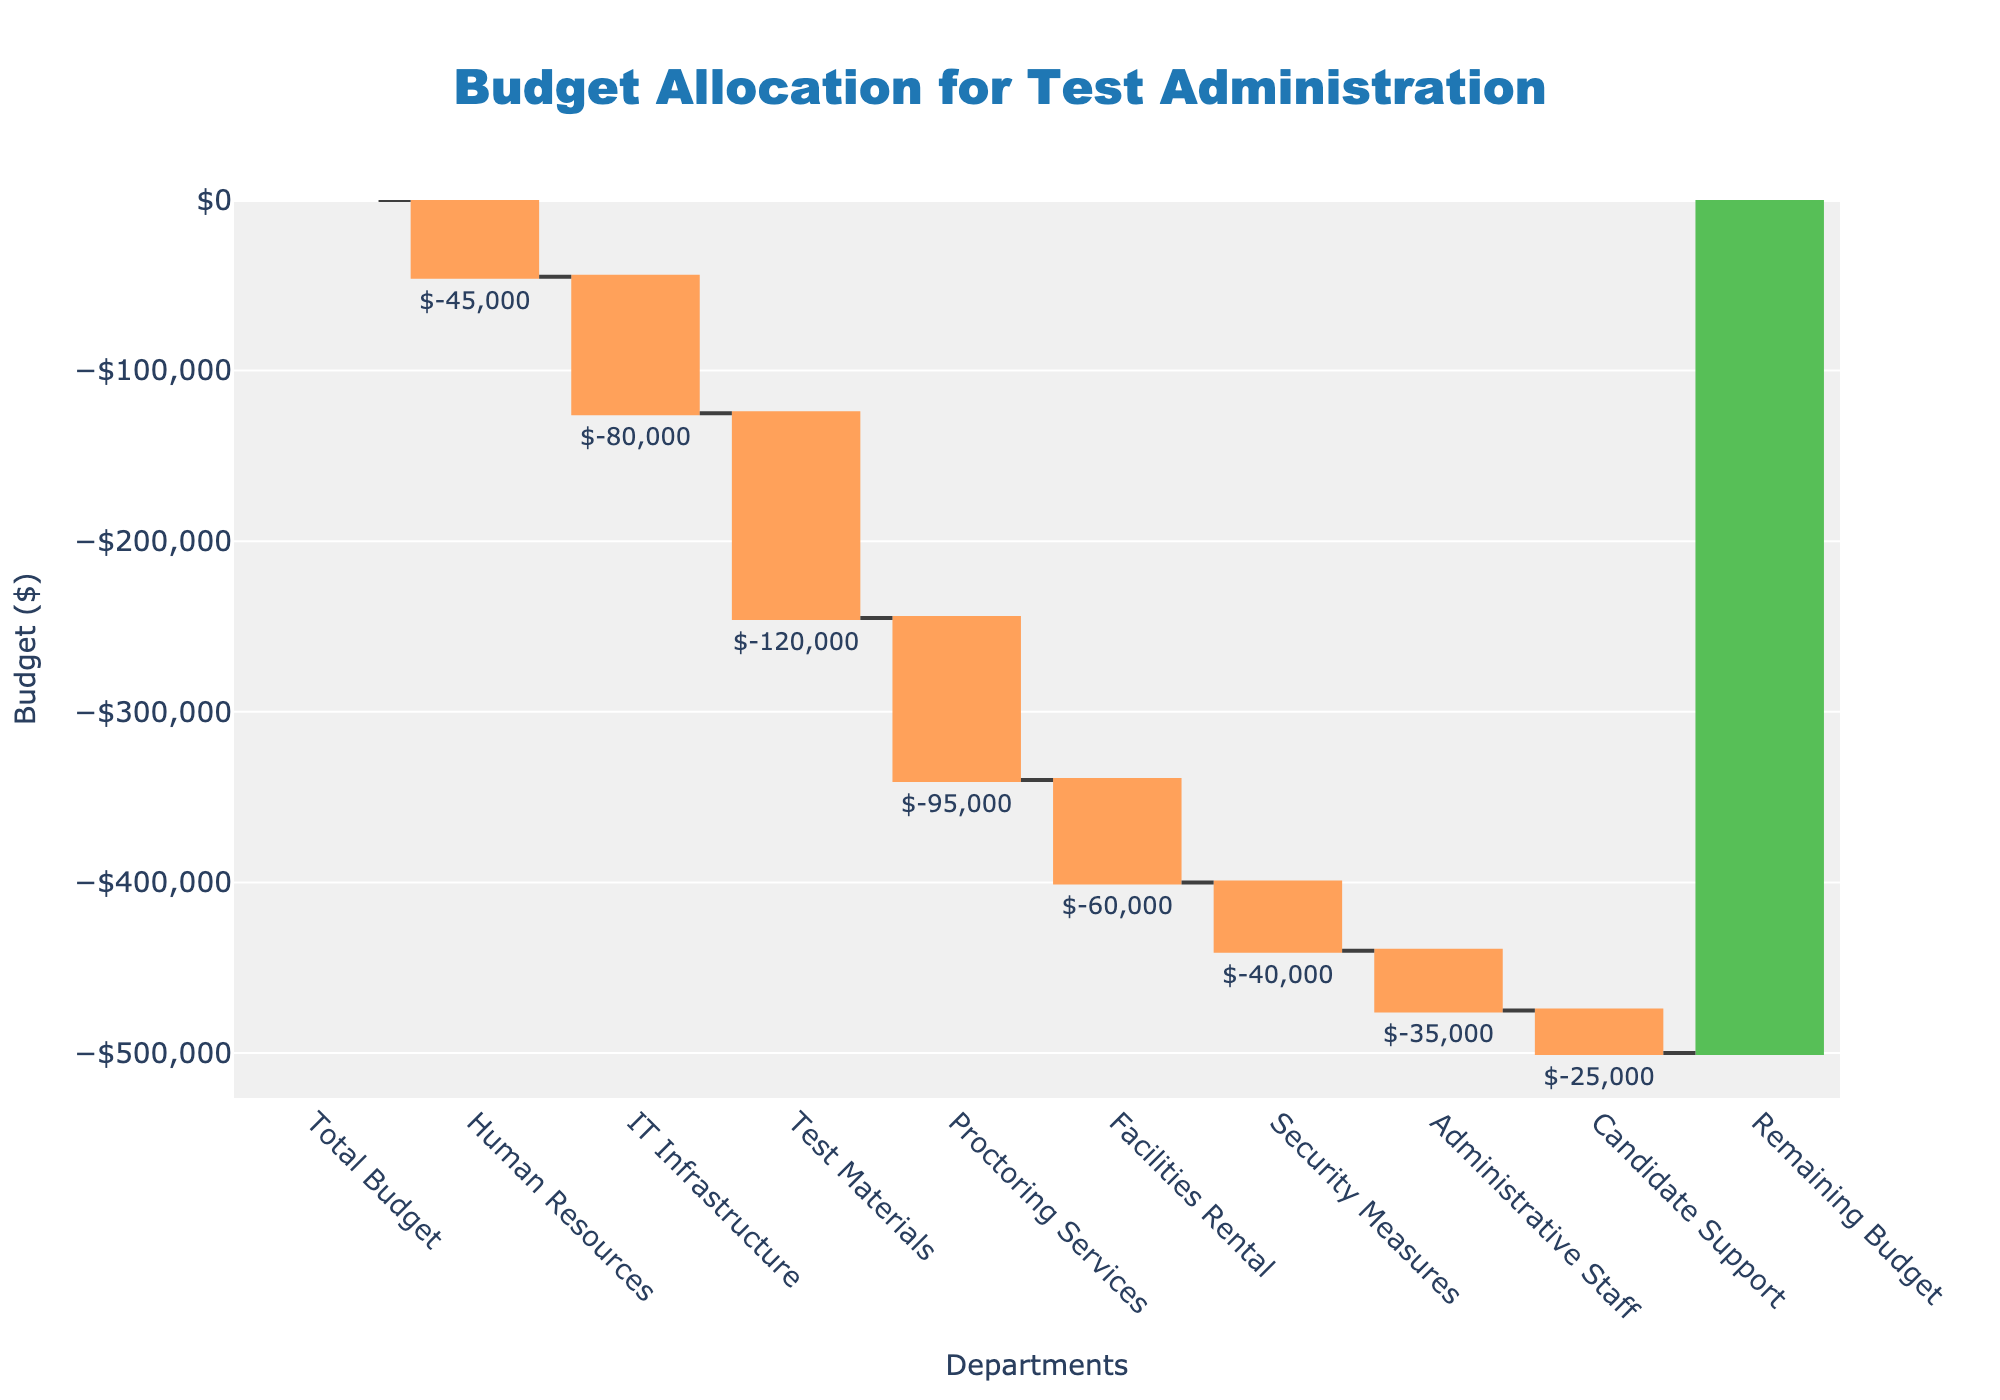What's the title of the chart? Look at the top of the chart for the text that describes its overall subject.
Answer: Budget Allocation for Test Administration How many departments are listed in the chart? Count the number of unique department names along the x-axis, excluding the 'Total Budget' and 'Remaining Budget'.
Answer: 8 What is the initial total budget? Identify the first bar in the chart which represents the total budget, indicated by a green color.
Answer: $500,000 Which department receives the largest budget allocation cut? Find the department with the largest negative value among the red-colored bars.
Answer: Test Materials What is the total budget reduction across all departments? Add up all the negative budget allocations shown in the waterfall chart. Sum(-45000 - 80000 - 120000 - 95000 - 60000 - 40000 - 35000 - 25000).
Answer: $500,000 Compare the budget cuts for IT Infrastructure and Administrative Staff. Which one is greater? Compare the negative values for IT Infrastructure and Administrative Staff and note which is larger in magnitude.
Answer: IT Infrastructure Which department had the smallest budget allocation cut? Identify the smallest negative value among the red-colored bars on the chart.
Answer: Candidate Support How much budget remains after all allocations? Look at the value associated with the 'Remaining Budget' and infer it from the chart, which should be straightforward as this is a validating step for the data.
Answer: $0 What is the combined budget allocation cut for Human Resources, Proctoring Services, and Security Measures? Sum the mentioned individual budget allocations: -45000 + -95000 + -40000.
Answer: $180,000 What color represents the total budget in the chart? Identify the color used for the 'Total Budget' bar, which is unique from the other budget cuts.
Answer: Green 